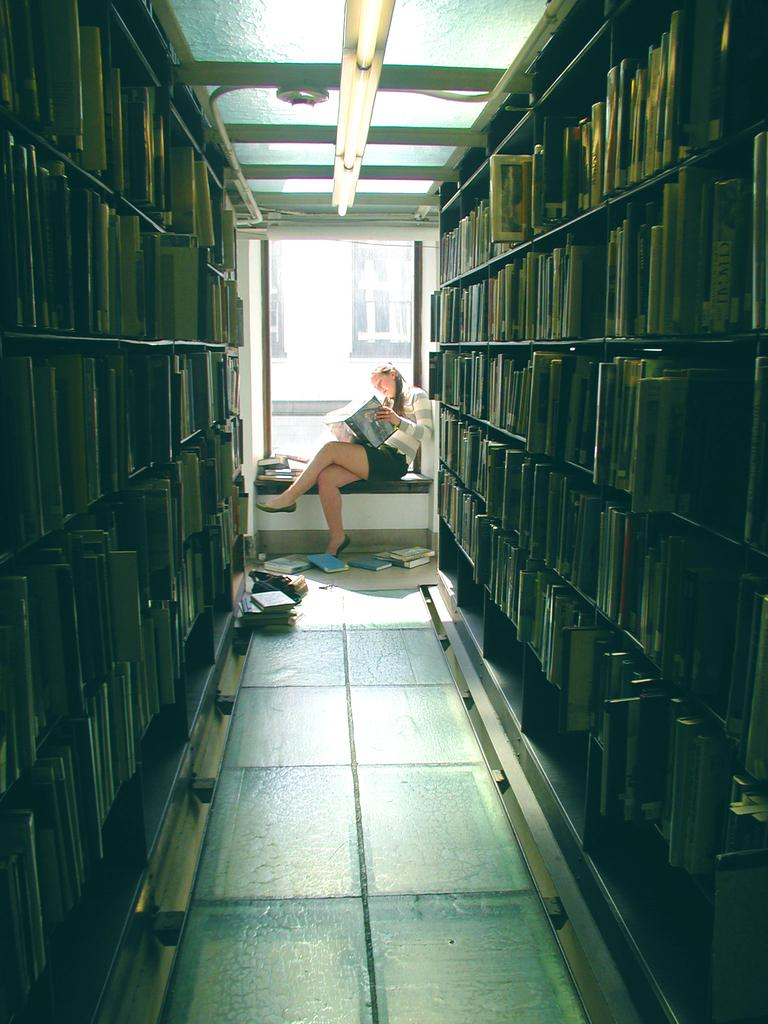What can be seen in the racks in the image? There are books in the racks. What is the person in the image doing? The person is sitting and holding a book. What is a feature of the room visible in the image? There is a window in the image. What is providing illumination in the image? There are lights visible in the image. Where are additional books located in the image? There are books on the floor. What word is written on the balloon in the image? There is no balloon present in the image, so no word can be read from it. How is the person measuring the books in the image? There is no indication of measuring in the image; the person is simply holding a book. 